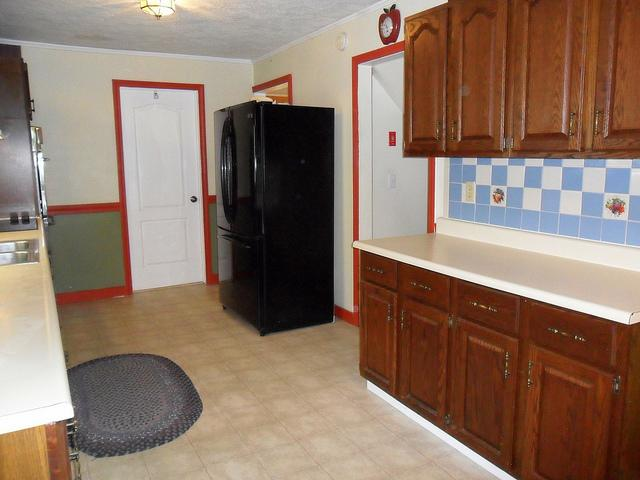What material is the floor made of? linoleum 